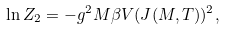<formula> <loc_0><loc_0><loc_500><loc_500>\ln Z _ { 2 } = - g ^ { 2 } M \beta V ( J ( M , T ) ) ^ { 2 } ,</formula> 